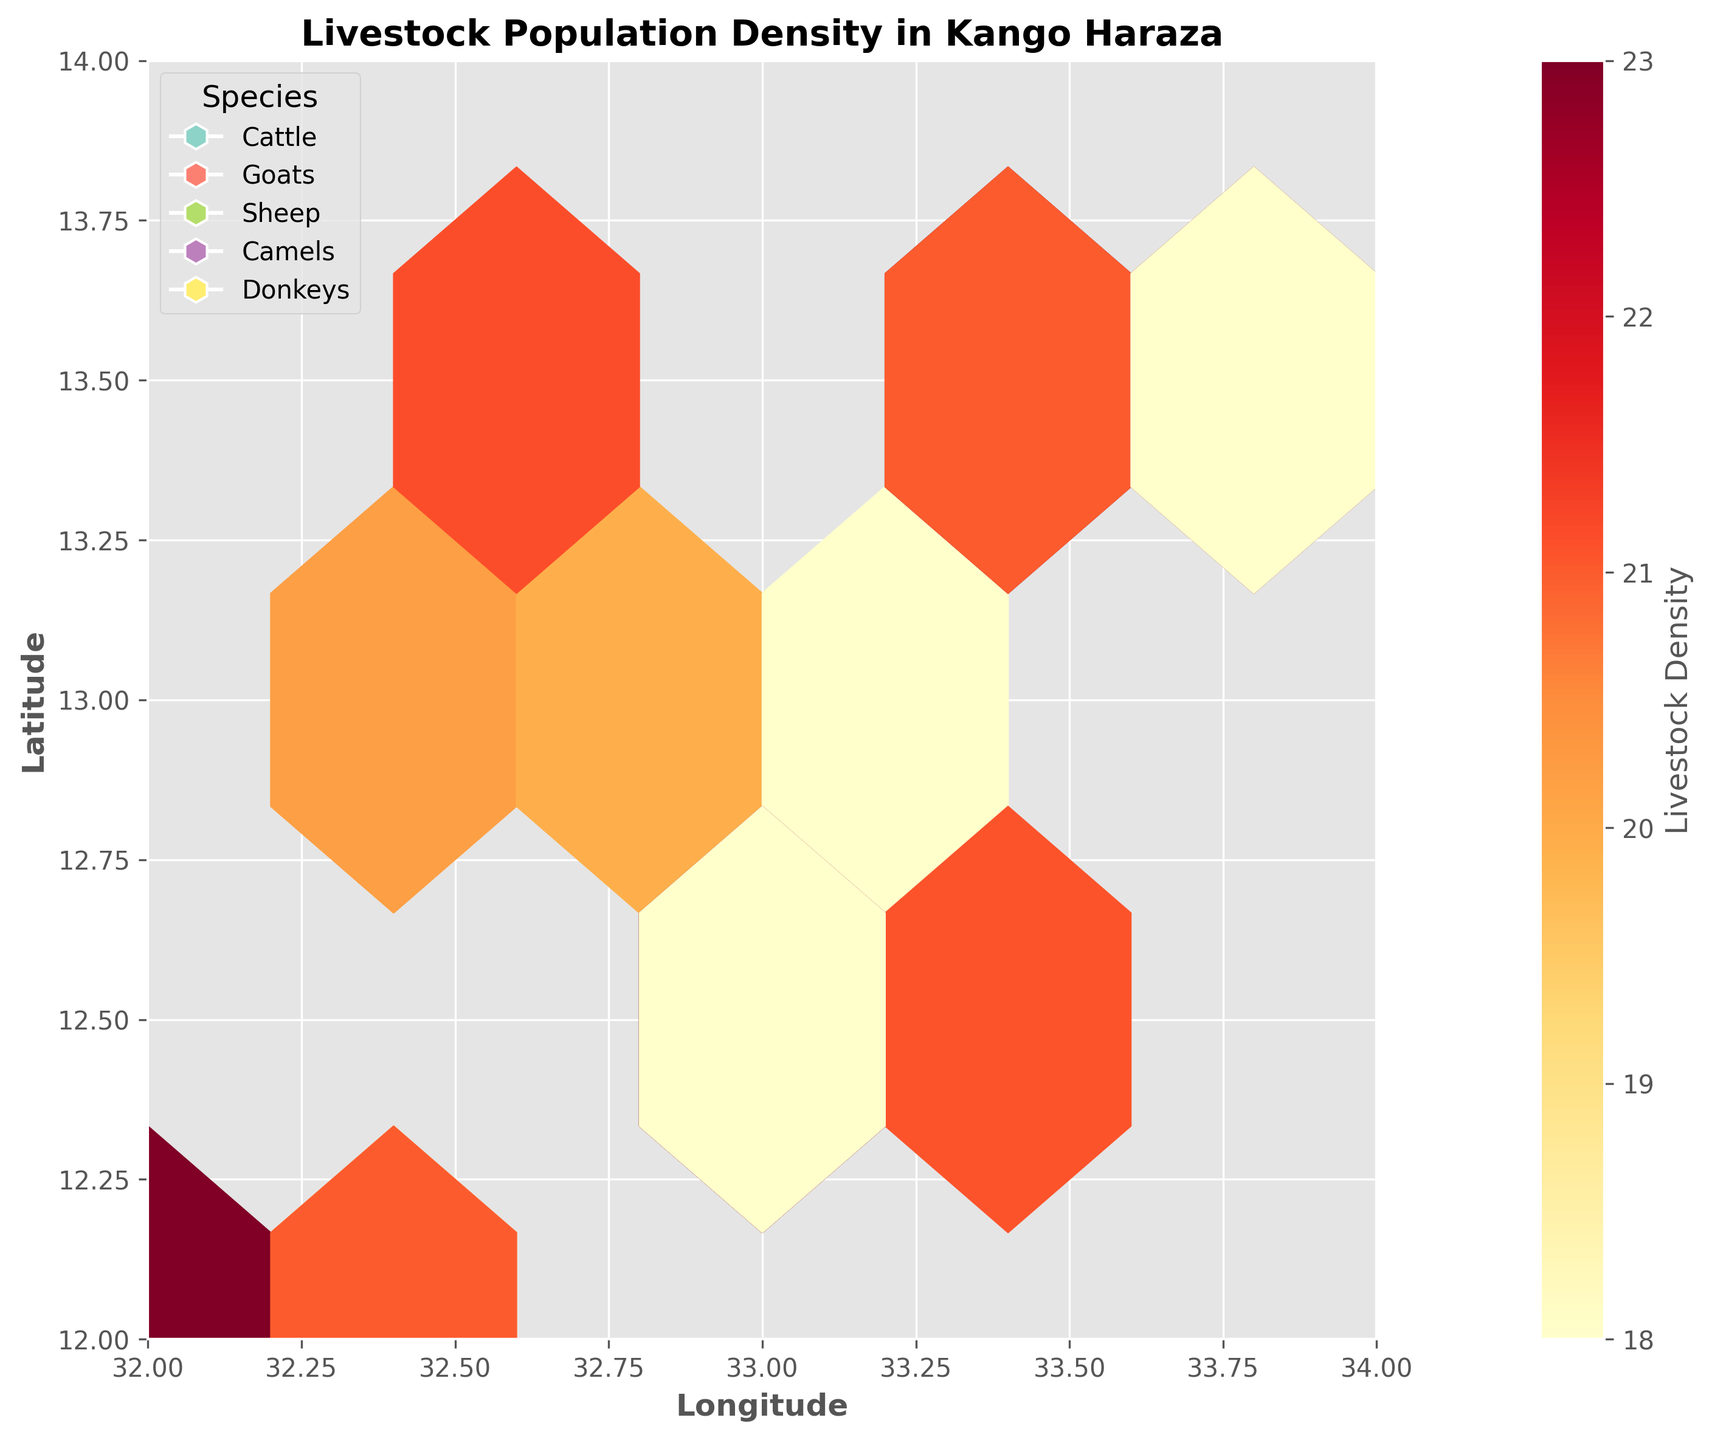What species of livestock are included in the plot? The legend in the plot shows different types of species represented by different color markers.
Answer: Cattle, Goats, Sheep, Camels, Donkeys What does the color intensity in the hexagons represent? The color intensity gradient shown in the color bar indicates the livestock density, with darker colors representing higher density.
Answer: Livestock Density Where is the highest density of Goats located on the plot? The plot shows a high density of Goats around the coordinates (32.9, 12.6) as indicated by the darker colored hexagons in this area.
Answer: Around (32.9, 12.6) What is the general longitude range covered in the plot? The x-axis, labeled "Longitude," spans from 32 to 34 according to the axis limits.
Answer: 32 to 34 How does the livestock density of Cattle compare with that of Sheep around coordinates (32.4, 12.3)? By looking at the color intensities of the hexagons around (32.4, 12.3) for both species, Cattle has a higher density (darker color) compared to Sheep.
Answer: Cattle has higher density What is the visual difference in density between Camels and Donkeys? The hexagons representing Camels have lighter colors compared to those of Donkeys, indicating lower density.
Answer: Donkeys have higher density What species shows the lowest overall density on the plot? Observing the color and density indicated by the color bar, Camels have the lightest colors in the hexagons, indicating the lowest density.
Answer: Camels What is the average livestock density for Goats if we consider the hexagons around (33.5, 12.7) and (33.2, 13.1)? The densities are 66 and 58. Thus, the average is (66 + 58) / 2 = 62.
Answer: 62 How many major livestock types are being analyzed around Kango Haraza according to the legend? The legend near the plot displays different markers for each species, showing a total of five different types.
Answer: 5 Which species tends to populate the most southeastern part of the plot (based on density and location)? Observing the lower right part of the plot, Goats show relatively darker hexagons around coordinates like (33.5, 12.7) indicating a higher density in the southeastern part.
Answer: Goats 